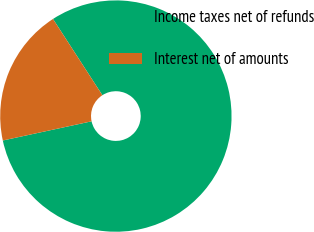Convert chart to OTSL. <chart><loc_0><loc_0><loc_500><loc_500><pie_chart><fcel>Income taxes net of refunds<fcel>Interest net of amounts<nl><fcel>80.76%<fcel>19.24%<nl></chart> 